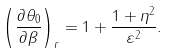Convert formula to latex. <formula><loc_0><loc_0><loc_500><loc_500>\left ( \frac { \partial { \theta } _ { 0 } } { \partial \beta } \right ) _ { r } = 1 + \frac { 1 + \eta ^ { 2 } } { \varepsilon ^ { 2 } } .</formula> 